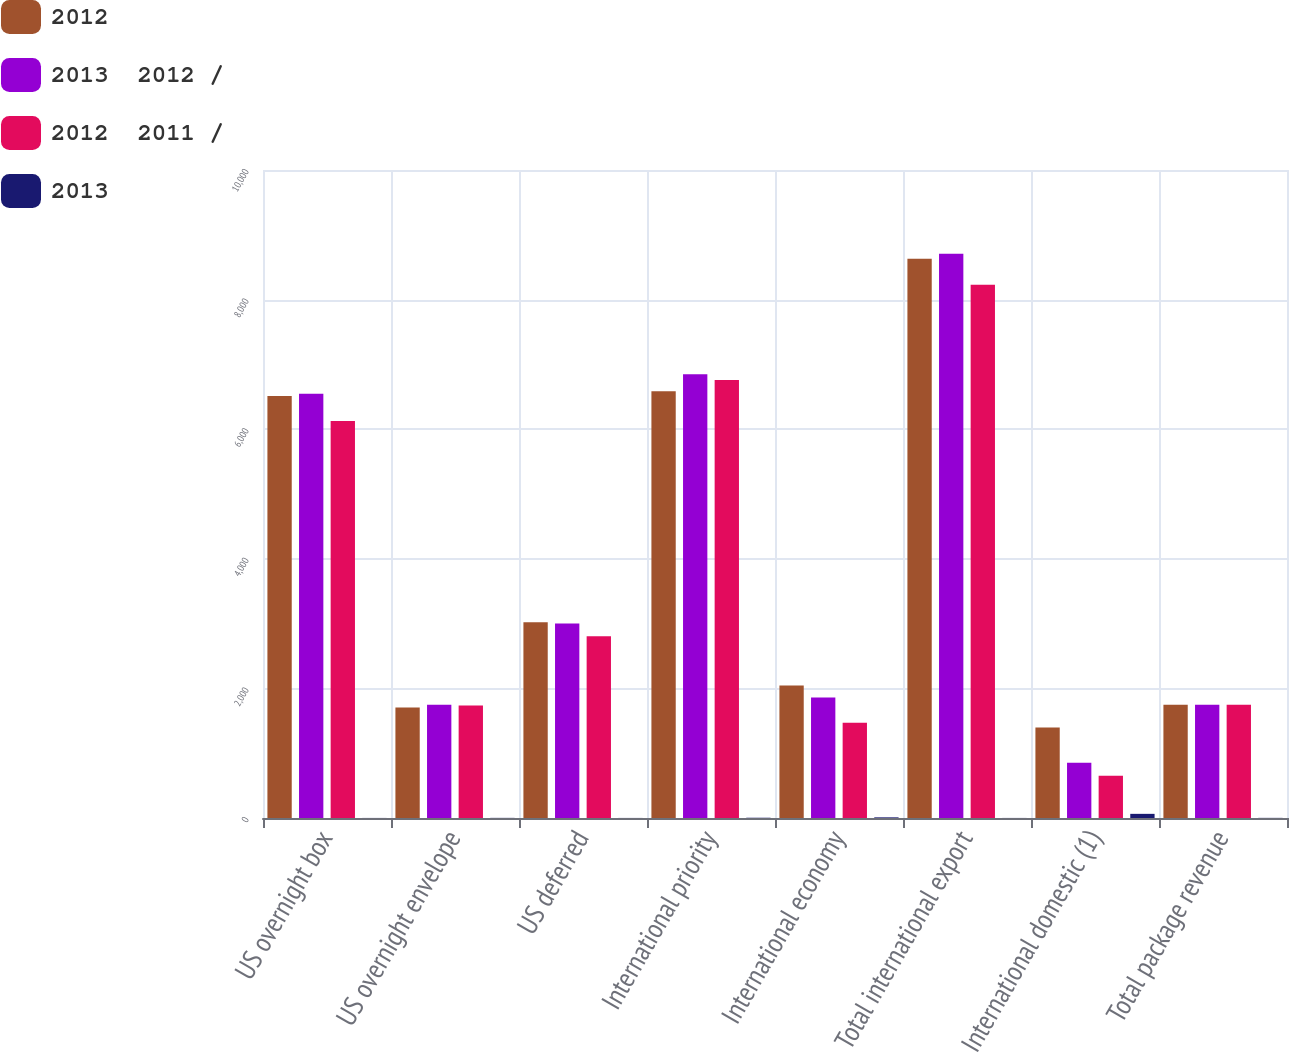Convert chart. <chart><loc_0><loc_0><loc_500><loc_500><stacked_bar_chart><ecel><fcel>US overnight box<fcel>US overnight envelope<fcel>US deferred<fcel>International priority<fcel>International economy<fcel>Total international export<fcel>International domestic (1)<fcel>Total package revenue<nl><fcel>2012<fcel>6513<fcel>1705<fcel>3020<fcel>6586<fcel>2046<fcel>8632<fcel>1398<fcel>1747<nl><fcel>2013  2012 /<fcel>6546<fcel>1747<fcel>3001<fcel>6849<fcel>1859<fcel>8708<fcel>853<fcel>1747<nl><fcel>2012  2011 /<fcel>6128<fcel>1736<fcel>2805<fcel>6760<fcel>1468<fcel>8228<fcel>653<fcel>1747<nl><fcel>2013<fcel>1<fcel>2<fcel>1<fcel>4<fcel>10<fcel>1<fcel>64<fcel>2<nl></chart> 